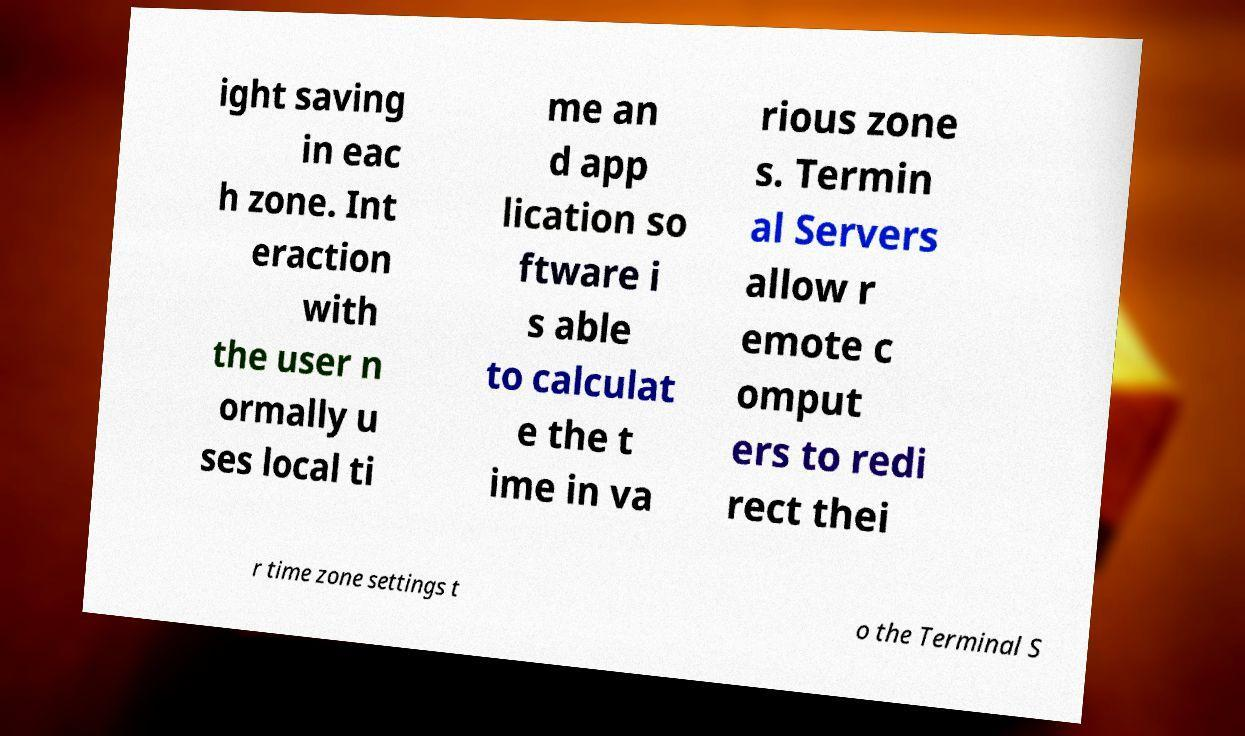There's text embedded in this image that I need extracted. Can you transcribe it verbatim? ight saving in eac h zone. Int eraction with the user n ormally u ses local ti me an d app lication so ftware i s able to calculat e the t ime in va rious zone s. Termin al Servers allow r emote c omput ers to redi rect thei r time zone settings t o the Terminal S 